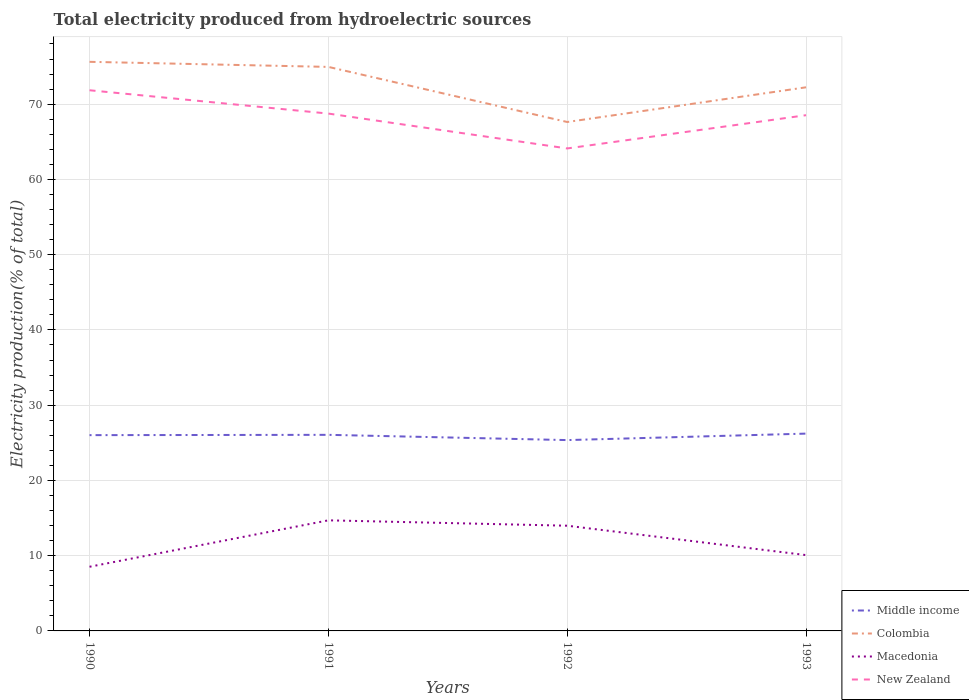How many different coloured lines are there?
Provide a short and direct response. 4. Across all years, what is the maximum total electricity produced in Middle income?
Your response must be concise. 25.36. What is the total total electricity produced in New Zealand in the graph?
Offer a very short reply. 4.63. What is the difference between the highest and the second highest total electricity produced in Colombia?
Your answer should be very brief. 8. How many lines are there?
Ensure brevity in your answer.  4. Are the values on the major ticks of Y-axis written in scientific E-notation?
Provide a short and direct response. No. Where does the legend appear in the graph?
Ensure brevity in your answer.  Bottom right. How many legend labels are there?
Ensure brevity in your answer.  4. What is the title of the graph?
Your response must be concise. Total electricity produced from hydroelectric sources. What is the label or title of the X-axis?
Provide a succinct answer. Years. What is the label or title of the Y-axis?
Provide a succinct answer. Electricity production(% of total). What is the Electricity production(% of total) of Middle income in 1990?
Make the answer very short. 26.02. What is the Electricity production(% of total) of Colombia in 1990?
Provide a short and direct response. 75.63. What is the Electricity production(% of total) of Macedonia in 1990?
Ensure brevity in your answer.  8.53. What is the Electricity production(% of total) of New Zealand in 1990?
Make the answer very short. 71.85. What is the Electricity production(% of total) in Middle income in 1991?
Your answer should be very brief. 26.06. What is the Electricity production(% of total) of Colombia in 1991?
Provide a short and direct response. 74.96. What is the Electricity production(% of total) in Macedonia in 1991?
Give a very brief answer. 14.7. What is the Electricity production(% of total) of New Zealand in 1991?
Provide a succinct answer. 68.75. What is the Electricity production(% of total) in Middle income in 1992?
Your response must be concise. 25.36. What is the Electricity production(% of total) of Colombia in 1992?
Your answer should be compact. 67.63. What is the Electricity production(% of total) of Macedonia in 1992?
Provide a succinct answer. 13.98. What is the Electricity production(% of total) of New Zealand in 1992?
Your answer should be very brief. 64.12. What is the Electricity production(% of total) of Middle income in 1993?
Offer a very short reply. 26.22. What is the Electricity production(% of total) of Colombia in 1993?
Ensure brevity in your answer.  72.25. What is the Electricity production(% of total) in Macedonia in 1993?
Provide a short and direct response. 10.08. What is the Electricity production(% of total) of New Zealand in 1993?
Give a very brief answer. 68.54. Across all years, what is the maximum Electricity production(% of total) in Middle income?
Your answer should be compact. 26.22. Across all years, what is the maximum Electricity production(% of total) in Colombia?
Make the answer very short. 75.63. Across all years, what is the maximum Electricity production(% of total) of Macedonia?
Your answer should be very brief. 14.7. Across all years, what is the maximum Electricity production(% of total) in New Zealand?
Make the answer very short. 71.85. Across all years, what is the minimum Electricity production(% of total) of Middle income?
Offer a terse response. 25.36. Across all years, what is the minimum Electricity production(% of total) of Colombia?
Your answer should be compact. 67.63. Across all years, what is the minimum Electricity production(% of total) in Macedonia?
Your response must be concise. 8.53. Across all years, what is the minimum Electricity production(% of total) in New Zealand?
Give a very brief answer. 64.12. What is the total Electricity production(% of total) of Middle income in the graph?
Provide a short and direct response. 103.66. What is the total Electricity production(% of total) in Colombia in the graph?
Your answer should be compact. 290.46. What is the total Electricity production(% of total) of Macedonia in the graph?
Ensure brevity in your answer.  47.28. What is the total Electricity production(% of total) in New Zealand in the graph?
Your answer should be very brief. 273.26. What is the difference between the Electricity production(% of total) in Middle income in 1990 and that in 1991?
Offer a very short reply. -0.04. What is the difference between the Electricity production(% of total) in Colombia in 1990 and that in 1991?
Give a very brief answer. 0.68. What is the difference between the Electricity production(% of total) of Macedonia in 1990 and that in 1991?
Keep it short and to the point. -6.17. What is the difference between the Electricity production(% of total) of New Zealand in 1990 and that in 1991?
Offer a very short reply. 3.1. What is the difference between the Electricity production(% of total) in Middle income in 1990 and that in 1992?
Offer a terse response. 0.66. What is the difference between the Electricity production(% of total) in Colombia in 1990 and that in 1992?
Give a very brief answer. 8. What is the difference between the Electricity production(% of total) of Macedonia in 1990 and that in 1992?
Provide a short and direct response. -5.45. What is the difference between the Electricity production(% of total) in New Zealand in 1990 and that in 1992?
Keep it short and to the point. 7.73. What is the difference between the Electricity production(% of total) in Middle income in 1990 and that in 1993?
Keep it short and to the point. -0.2. What is the difference between the Electricity production(% of total) in Colombia in 1990 and that in 1993?
Your answer should be very brief. 3.39. What is the difference between the Electricity production(% of total) in Macedonia in 1990 and that in 1993?
Keep it short and to the point. -1.55. What is the difference between the Electricity production(% of total) of New Zealand in 1990 and that in 1993?
Ensure brevity in your answer.  3.31. What is the difference between the Electricity production(% of total) of Middle income in 1991 and that in 1992?
Offer a very short reply. 0.7. What is the difference between the Electricity production(% of total) of Colombia in 1991 and that in 1992?
Your response must be concise. 7.32. What is the difference between the Electricity production(% of total) in Macedonia in 1991 and that in 1992?
Your answer should be compact. 0.71. What is the difference between the Electricity production(% of total) in New Zealand in 1991 and that in 1992?
Make the answer very short. 4.63. What is the difference between the Electricity production(% of total) in Middle income in 1991 and that in 1993?
Offer a terse response. -0.16. What is the difference between the Electricity production(% of total) in Colombia in 1991 and that in 1993?
Make the answer very short. 2.71. What is the difference between the Electricity production(% of total) in Macedonia in 1991 and that in 1993?
Your response must be concise. 4.62. What is the difference between the Electricity production(% of total) of New Zealand in 1991 and that in 1993?
Keep it short and to the point. 0.22. What is the difference between the Electricity production(% of total) in Middle income in 1992 and that in 1993?
Your response must be concise. -0.86. What is the difference between the Electricity production(% of total) in Colombia in 1992 and that in 1993?
Your answer should be compact. -4.61. What is the difference between the Electricity production(% of total) in Macedonia in 1992 and that in 1993?
Your answer should be very brief. 3.9. What is the difference between the Electricity production(% of total) in New Zealand in 1992 and that in 1993?
Your response must be concise. -4.42. What is the difference between the Electricity production(% of total) of Middle income in 1990 and the Electricity production(% of total) of Colombia in 1991?
Your answer should be compact. -48.94. What is the difference between the Electricity production(% of total) in Middle income in 1990 and the Electricity production(% of total) in Macedonia in 1991?
Ensure brevity in your answer.  11.32. What is the difference between the Electricity production(% of total) of Middle income in 1990 and the Electricity production(% of total) of New Zealand in 1991?
Offer a terse response. -42.73. What is the difference between the Electricity production(% of total) in Colombia in 1990 and the Electricity production(% of total) in Macedonia in 1991?
Give a very brief answer. 60.93. What is the difference between the Electricity production(% of total) of Colombia in 1990 and the Electricity production(% of total) of New Zealand in 1991?
Ensure brevity in your answer.  6.88. What is the difference between the Electricity production(% of total) in Macedonia in 1990 and the Electricity production(% of total) in New Zealand in 1991?
Give a very brief answer. -60.23. What is the difference between the Electricity production(% of total) of Middle income in 1990 and the Electricity production(% of total) of Colombia in 1992?
Keep it short and to the point. -41.61. What is the difference between the Electricity production(% of total) in Middle income in 1990 and the Electricity production(% of total) in Macedonia in 1992?
Offer a terse response. 12.04. What is the difference between the Electricity production(% of total) of Middle income in 1990 and the Electricity production(% of total) of New Zealand in 1992?
Your answer should be very brief. -38.1. What is the difference between the Electricity production(% of total) of Colombia in 1990 and the Electricity production(% of total) of Macedonia in 1992?
Provide a succinct answer. 61.65. What is the difference between the Electricity production(% of total) in Colombia in 1990 and the Electricity production(% of total) in New Zealand in 1992?
Provide a succinct answer. 11.51. What is the difference between the Electricity production(% of total) of Macedonia in 1990 and the Electricity production(% of total) of New Zealand in 1992?
Ensure brevity in your answer.  -55.59. What is the difference between the Electricity production(% of total) of Middle income in 1990 and the Electricity production(% of total) of Colombia in 1993?
Your answer should be compact. -46.23. What is the difference between the Electricity production(% of total) in Middle income in 1990 and the Electricity production(% of total) in Macedonia in 1993?
Your response must be concise. 15.94. What is the difference between the Electricity production(% of total) in Middle income in 1990 and the Electricity production(% of total) in New Zealand in 1993?
Your response must be concise. -42.52. What is the difference between the Electricity production(% of total) of Colombia in 1990 and the Electricity production(% of total) of Macedonia in 1993?
Make the answer very short. 65.55. What is the difference between the Electricity production(% of total) of Colombia in 1990 and the Electricity production(% of total) of New Zealand in 1993?
Make the answer very short. 7.09. What is the difference between the Electricity production(% of total) of Macedonia in 1990 and the Electricity production(% of total) of New Zealand in 1993?
Your response must be concise. -60.01. What is the difference between the Electricity production(% of total) of Middle income in 1991 and the Electricity production(% of total) of Colombia in 1992?
Offer a terse response. -41.57. What is the difference between the Electricity production(% of total) of Middle income in 1991 and the Electricity production(% of total) of Macedonia in 1992?
Make the answer very short. 12.08. What is the difference between the Electricity production(% of total) of Middle income in 1991 and the Electricity production(% of total) of New Zealand in 1992?
Your answer should be very brief. -38.06. What is the difference between the Electricity production(% of total) of Colombia in 1991 and the Electricity production(% of total) of Macedonia in 1992?
Ensure brevity in your answer.  60.97. What is the difference between the Electricity production(% of total) of Colombia in 1991 and the Electricity production(% of total) of New Zealand in 1992?
Keep it short and to the point. 10.84. What is the difference between the Electricity production(% of total) of Macedonia in 1991 and the Electricity production(% of total) of New Zealand in 1992?
Provide a short and direct response. -49.42. What is the difference between the Electricity production(% of total) in Middle income in 1991 and the Electricity production(% of total) in Colombia in 1993?
Offer a terse response. -46.19. What is the difference between the Electricity production(% of total) of Middle income in 1991 and the Electricity production(% of total) of Macedonia in 1993?
Ensure brevity in your answer.  15.98. What is the difference between the Electricity production(% of total) of Middle income in 1991 and the Electricity production(% of total) of New Zealand in 1993?
Your answer should be very brief. -42.48. What is the difference between the Electricity production(% of total) in Colombia in 1991 and the Electricity production(% of total) in Macedonia in 1993?
Your answer should be compact. 64.88. What is the difference between the Electricity production(% of total) in Colombia in 1991 and the Electricity production(% of total) in New Zealand in 1993?
Give a very brief answer. 6.42. What is the difference between the Electricity production(% of total) in Macedonia in 1991 and the Electricity production(% of total) in New Zealand in 1993?
Your answer should be very brief. -53.84. What is the difference between the Electricity production(% of total) of Middle income in 1992 and the Electricity production(% of total) of Colombia in 1993?
Make the answer very short. -46.88. What is the difference between the Electricity production(% of total) of Middle income in 1992 and the Electricity production(% of total) of Macedonia in 1993?
Give a very brief answer. 15.28. What is the difference between the Electricity production(% of total) of Middle income in 1992 and the Electricity production(% of total) of New Zealand in 1993?
Provide a succinct answer. -43.18. What is the difference between the Electricity production(% of total) of Colombia in 1992 and the Electricity production(% of total) of Macedonia in 1993?
Your answer should be very brief. 57.56. What is the difference between the Electricity production(% of total) in Colombia in 1992 and the Electricity production(% of total) in New Zealand in 1993?
Your answer should be very brief. -0.9. What is the difference between the Electricity production(% of total) in Macedonia in 1992 and the Electricity production(% of total) in New Zealand in 1993?
Your answer should be very brief. -54.55. What is the average Electricity production(% of total) in Middle income per year?
Make the answer very short. 25.92. What is the average Electricity production(% of total) of Colombia per year?
Offer a terse response. 72.62. What is the average Electricity production(% of total) of Macedonia per year?
Give a very brief answer. 11.82. What is the average Electricity production(% of total) of New Zealand per year?
Provide a short and direct response. 68.31. In the year 1990, what is the difference between the Electricity production(% of total) of Middle income and Electricity production(% of total) of Colombia?
Ensure brevity in your answer.  -49.61. In the year 1990, what is the difference between the Electricity production(% of total) of Middle income and Electricity production(% of total) of Macedonia?
Offer a very short reply. 17.49. In the year 1990, what is the difference between the Electricity production(% of total) in Middle income and Electricity production(% of total) in New Zealand?
Offer a very short reply. -45.83. In the year 1990, what is the difference between the Electricity production(% of total) of Colombia and Electricity production(% of total) of Macedonia?
Offer a terse response. 67.1. In the year 1990, what is the difference between the Electricity production(% of total) in Colombia and Electricity production(% of total) in New Zealand?
Ensure brevity in your answer.  3.78. In the year 1990, what is the difference between the Electricity production(% of total) of Macedonia and Electricity production(% of total) of New Zealand?
Provide a succinct answer. -63.32. In the year 1991, what is the difference between the Electricity production(% of total) of Middle income and Electricity production(% of total) of Colombia?
Your response must be concise. -48.9. In the year 1991, what is the difference between the Electricity production(% of total) of Middle income and Electricity production(% of total) of Macedonia?
Provide a succinct answer. 11.36. In the year 1991, what is the difference between the Electricity production(% of total) of Middle income and Electricity production(% of total) of New Zealand?
Make the answer very short. -42.69. In the year 1991, what is the difference between the Electricity production(% of total) in Colombia and Electricity production(% of total) in Macedonia?
Your response must be concise. 60.26. In the year 1991, what is the difference between the Electricity production(% of total) of Colombia and Electricity production(% of total) of New Zealand?
Provide a succinct answer. 6.2. In the year 1991, what is the difference between the Electricity production(% of total) in Macedonia and Electricity production(% of total) in New Zealand?
Keep it short and to the point. -54.06. In the year 1992, what is the difference between the Electricity production(% of total) in Middle income and Electricity production(% of total) in Colombia?
Make the answer very short. -42.27. In the year 1992, what is the difference between the Electricity production(% of total) in Middle income and Electricity production(% of total) in Macedonia?
Make the answer very short. 11.38. In the year 1992, what is the difference between the Electricity production(% of total) of Middle income and Electricity production(% of total) of New Zealand?
Provide a succinct answer. -38.76. In the year 1992, what is the difference between the Electricity production(% of total) in Colombia and Electricity production(% of total) in Macedonia?
Your response must be concise. 53.65. In the year 1992, what is the difference between the Electricity production(% of total) in Colombia and Electricity production(% of total) in New Zealand?
Ensure brevity in your answer.  3.51. In the year 1992, what is the difference between the Electricity production(% of total) of Macedonia and Electricity production(% of total) of New Zealand?
Offer a very short reply. -50.14. In the year 1993, what is the difference between the Electricity production(% of total) in Middle income and Electricity production(% of total) in Colombia?
Offer a terse response. -46.02. In the year 1993, what is the difference between the Electricity production(% of total) of Middle income and Electricity production(% of total) of Macedonia?
Provide a short and direct response. 16.14. In the year 1993, what is the difference between the Electricity production(% of total) of Middle income and Electricity production(% of total) of New Zealand?
Provide a succinct answer. -42.32. In the year 1993, what is the difference between the Electricity production(% of total) in Colombia and Electricity production(% of total) in Macedonia?
Provide a short and direct response. 62.17. In the year 1993, what is the difference between the Electricity production(% of total) in Colombia and Electricity production(% of total) in New Zealand?
Your answer should be compact. 3.71. In the year 1993, what is the difference between the Electricity production(% of total) in Macedonia and Electricity production(% of total) in New Zealand?
Provide a short and direct response. -58.46. What is the ratio of the Electricity production(% of total) in Middle income in 1990 to that in 1991?
Your answer should be very brief. 1. What is the ratio of the Electricity production(% of total) of Colombia in 1990 to that in 1991?
Your answer should be very brief. 1.01. What is the ratio of the Electricity production(% of total) of Macedonia in 1990 to that in 1991?
Offer a very short reply. 0.58. What is the ratio of the Electricity production(% of total) of New Zealand in 1990 to that in 1991?
Make the answer very short. 1.05. What is the ratio of the Electricity production(% of total) of Middle income in 1990 to that in 1992?
Give a very brief answer. 1.03. What is the ratio of the Electricity production(% of total) of Colombia in 1990 to that in 1992?
Offer a very short reply. 1.12. What is the ratio of the Electricity production(% of total) in Macedonia in 1990 to that in 1992?
Offer a very short reply. 0.61. What is the ratio of the Electricity production(% of total) of New Zealand in 1990 to that in 1992?
Keep it short and to the point. 1.12. What is the ratio of the Electricity production(% of total) of Colombia in 1990 to that in 1993?
Your answer should be compact. 1.05. What is the ratio of the Electricity production(% of total) of Macedonia in 1990 to that in 1993?
Offer a very short reply. 0.85. What is the ratio of the Electricity production(% of total) in New Zealand in 1990 to that in 1993?
Provide a succinct answer. 1.05. What is the ratio of the Electricity production(% of total) in Middle income in 1991 to that in 1992?
Offer a very short reply. 1.03. What is the ratio of the Electricity production(% of total) in Colombia in 1991 to that in 1992?
Give a very brief answer. 1.11. What is the ratio of the Electricity production(% of total) of Macedonia in 1991 to that in 1992?
Offer a terse response. 1.05. What is the ratio of the Electricity production(% of total) of New Zealand in 1991 to that in 1992?
Ensure brevity in your answer.  1.07. What is the ratio of the Electricity production(% of total) in Middle income in 1991 to that in 1993?
Provide a succinct answer. 0.99. What is the ratio of the Electricity production(% of total) in Colombia in 1991 to that in 1993?
Provide a short and direct response. 1.04. What is the ratio of the Electricity production(% of total) of Macedonia in 1991 to that in 1993?
Keep it short and to the point. 1.46. What is the ratio of the Electricity production(% of total) in New Zealand in 1991 to that in 1993?
Keep it short and to the point. 1. What is the ratio of the Electricity production(% of total) in Middle income in 1992 to that in 1993?
Your answer should be compact. 0.97. What is the ratio of the Electricity production(% of total) in Colombia in 1992 to that in 1993?
Your answer should be very brief. 0.94. What is the ratio of the Electricity production(% of total) of Macedonia in 1992 to that in 1993?
Your answer should be very brief. 1.39. What is the ratio of the Electricity production(% of total) of New Zealand in 1992 to that in 1993?
Offer a terse response. 0.94. What is the difference between the highest and the second highest Electricity production(% of total) in Middle income?
Make the answer very short. 0.16. What is the difference between the highest and the second highest Electricity production(% of total) of Colombia?
Give a very brief answer. 0.68. What is the difference between the highest and the second highest Electricity production(% of total) of Macedonia?
Offer a very short reply. 0.71. What is the difference between the highest and the second highest Electricity production(% of total) of New Zealand?
Give a very brief answer. 3.1. What is the difference between the highest and the lowest Electricity production(% of total) of Middle income?
Ensure brevity in your answer.  0.86. What is the difference between the highest and the lowest Electricity production(% of total) of Colombia?
Your answer should be very brief. 8. What is the difference between the highest and the lowest Electricity production(% of total) of Macedonia?
Provide a short and direct response. 6.17. What is the difference between the highest and the lowest Electricity production(% of total) of New Zealand?
Provide a succinct answer. 7.73. 